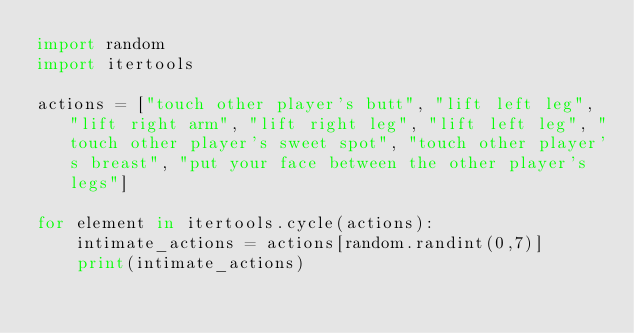Convert code to text. <code><loc_0><loc_0><loc_500><loc_500><_Python_>import random
import itertools

actions = ["touch other player's butt", "lift left leg", "lift right arm", "lift right leg", "lift left leg", "touch other player's sweet spot", "touch other player's breast", "put your face between the other player's legs"]

for element in itertools.cycle(actions):
    intimate_actions = actions[random.randint(0,7)]
    print(intimate_actions)
</code> 